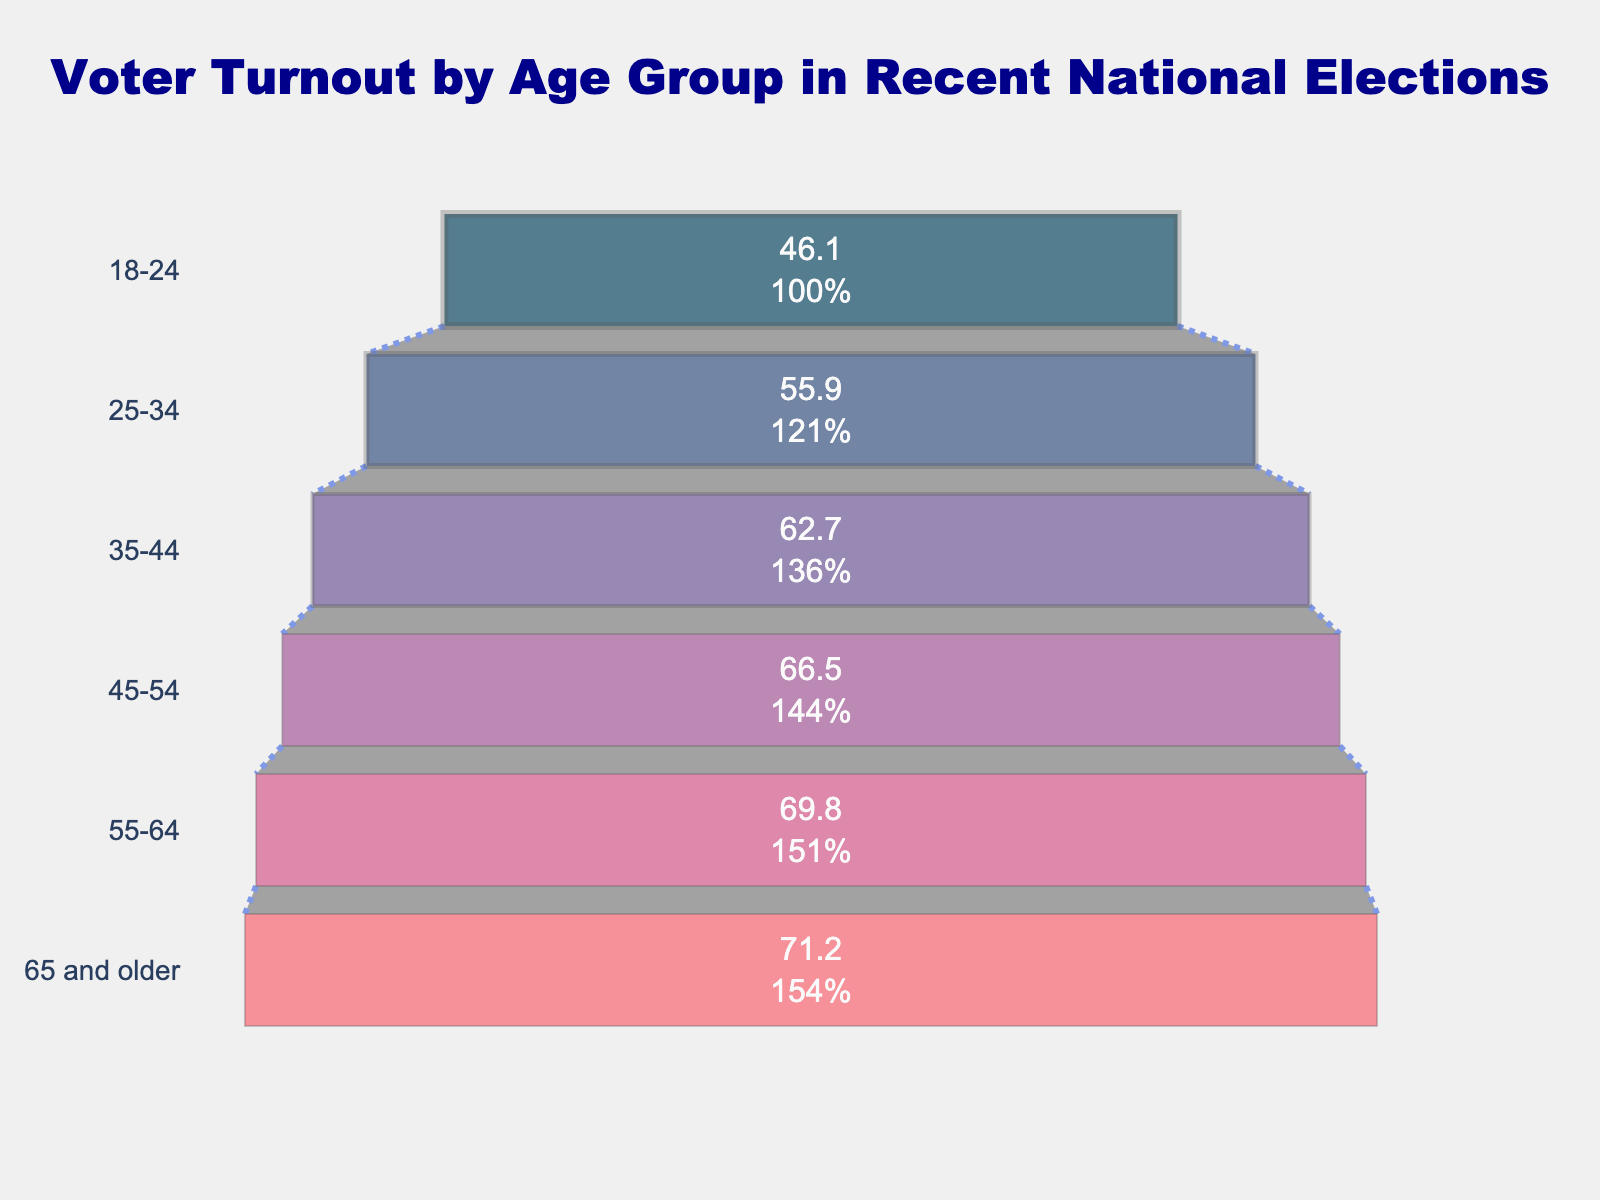What is the title of the figure? The title of the figure is prominently displayed at the top. It provides a clear description of the data being visualized.
Answer: Voter Turnout by Age Group in Recent National Elections What age group has the lowest voter turnout percentage? To find this, look at the age group with the smallest bar in the funnel chart. This group will be at the bottom since the funnel chart is ordered from highest to lowest.
Answer: 18-24 Which age group has the highest voter turnout percentage? The age group with the greatest voter turnout percentage will have the widest bar in the funnel chart, located at the top.
Answer: 65 and older What is the voter turnout percentage for the age group 45-54? Locate the bar in the funnel chart labeled "45-54" and read the voter turnout percentage displayed inside the bar.
Answer: 66.5% How does the voter turnout change as age increases? By observing the lengths and positions of the bars from bottom to top, you can see that voter turnout percentage generally increases with age.
Answer: Increases What is the total difference in voter turnout percentage between the age groups 18-24 and 65 and older? Subtract the percentage of the youngest age group (46.1%) from the percentage of the oldest age group (71.2%) to find the difference.
Answer: 25.1% How many age groups are displayed in the figure? Count the number of different age groups listed on the y-axis of the funnel chart.
Answer: 6 Which age group has a voter turnout percentage closest to 60%? Compare the voter turnout percentages (inside the bars) to identify the age group whose percentage is nearest to 60%.
Answer: 35-44 (62.7%) Which two age groups have a difference of around 10% in voter turnout percentages? Look for two adjacent bars whose percentages differ by approximately 10%. The differences between 25-34 (55.9%) and 35-44 (62.7%) is 6.8%. Compare other bars.
Answer: 25-34 and 35-44 If the voter turnout for the age group 25-34 were to increase by 10 percentage points, what would the new percentage be? Add 10 percentage points to the existing voter turnout percentage for the age group 25-34.
Answer: 65.9% 